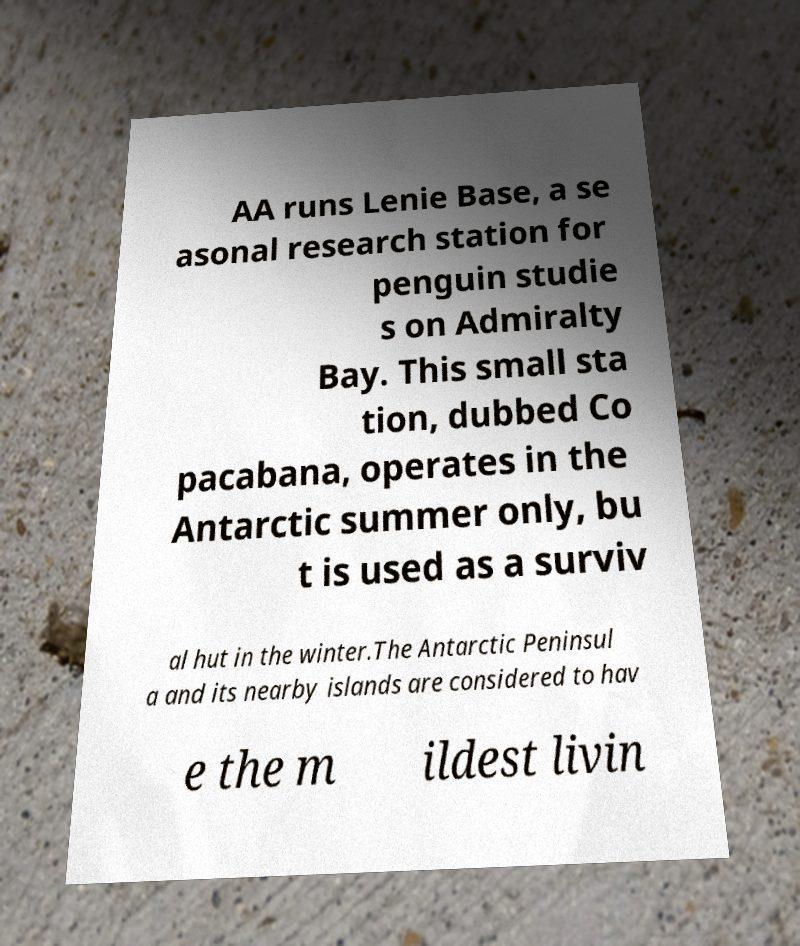What messages or text are displayed in this image? I need them in a readable, typed format. AA runs Lenie Base, a se asonal research station for penguin studie s on Admiralty Bay. This small sta tion, dubbed Co pacabana, operates in the Antarctic summer only, bu t is used as a surviv al hut in the winter.The Antarctic Peninsul a and its nearby islands are considered to hav e the m ildest livin 